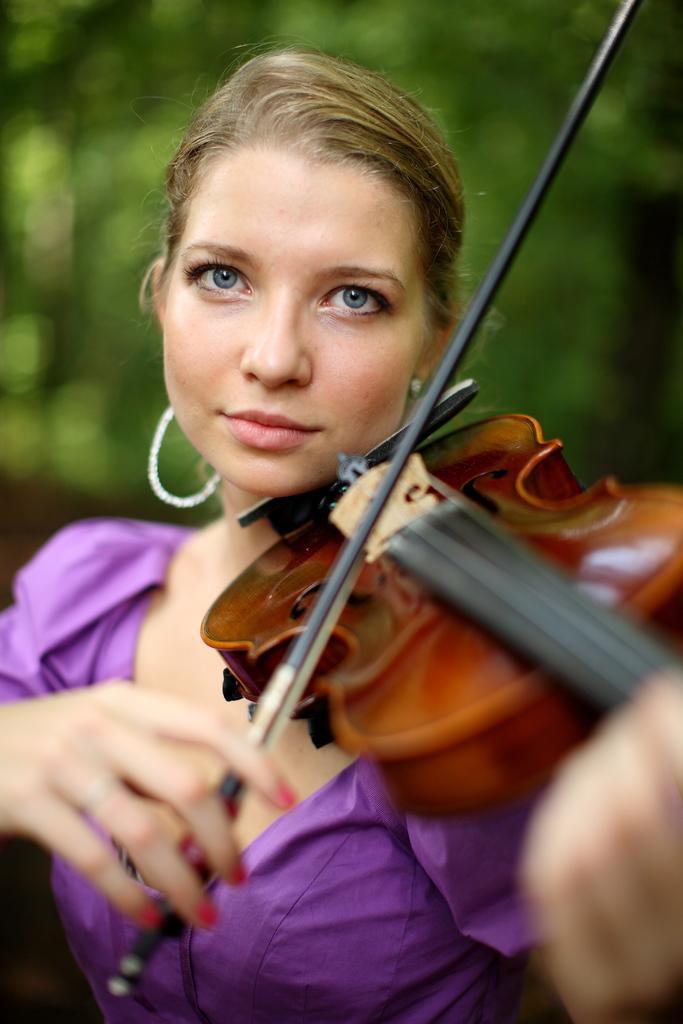Describe this image in one or two sentences. In this picture we can see a woman is playing a violin, it looks like a tree in the background, there is a blurry background. 